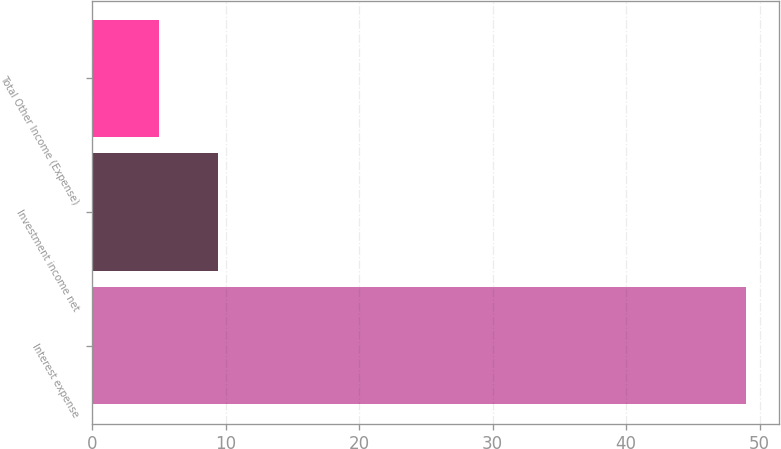Convert chart to OTSL. <chart><loc_0><loc_0><loc_500><loc_500><bar_chart><fcel>Interest expense<fcel>Investment income net<fcel>Total Other Income (Expense)<nl><fcel>49<fcel>9.4<fcel>5<nl></chart> 